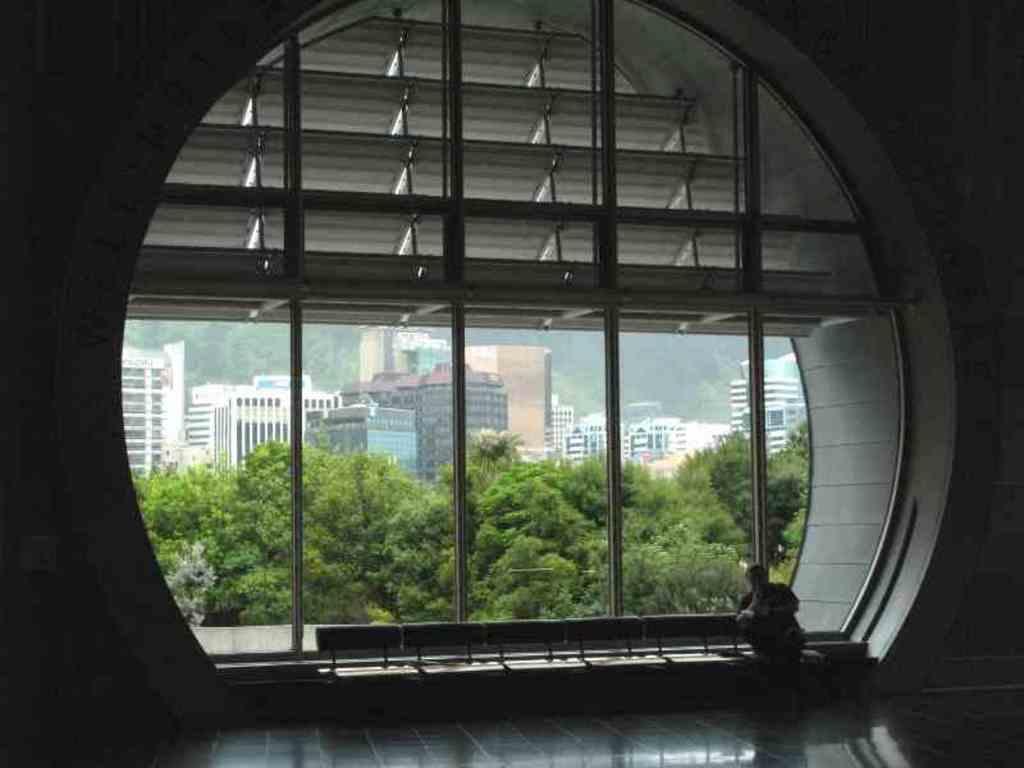Describe this image in one or two sentences. This picture is clicked inside. On the right there is a person and we can see the window and the wall and through the window we can see the sky, buildings and the trees. 